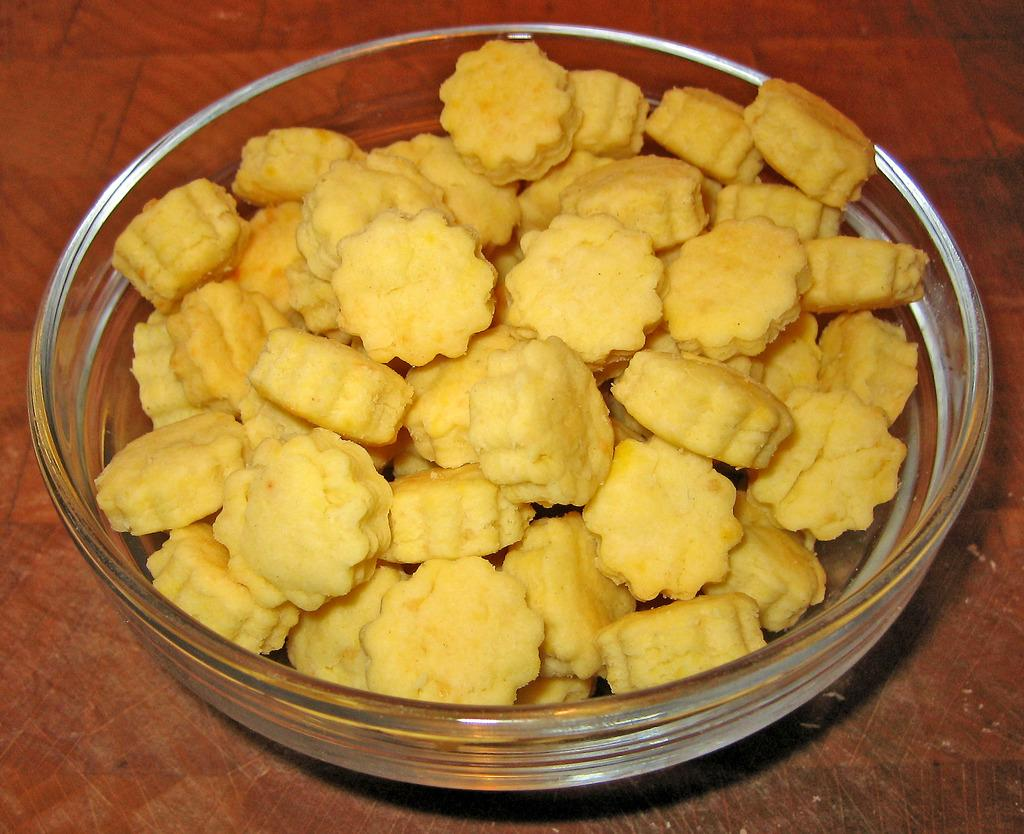What is in the bowl that is visible in the image? There is a bowl with food items in the image. What is the surface on which the bowl is placed? The bowl is on a wooden surface. What type of gate can be seen in the image? There is no gate present in the image; it only features a bowl with food items on a wooden surface. 